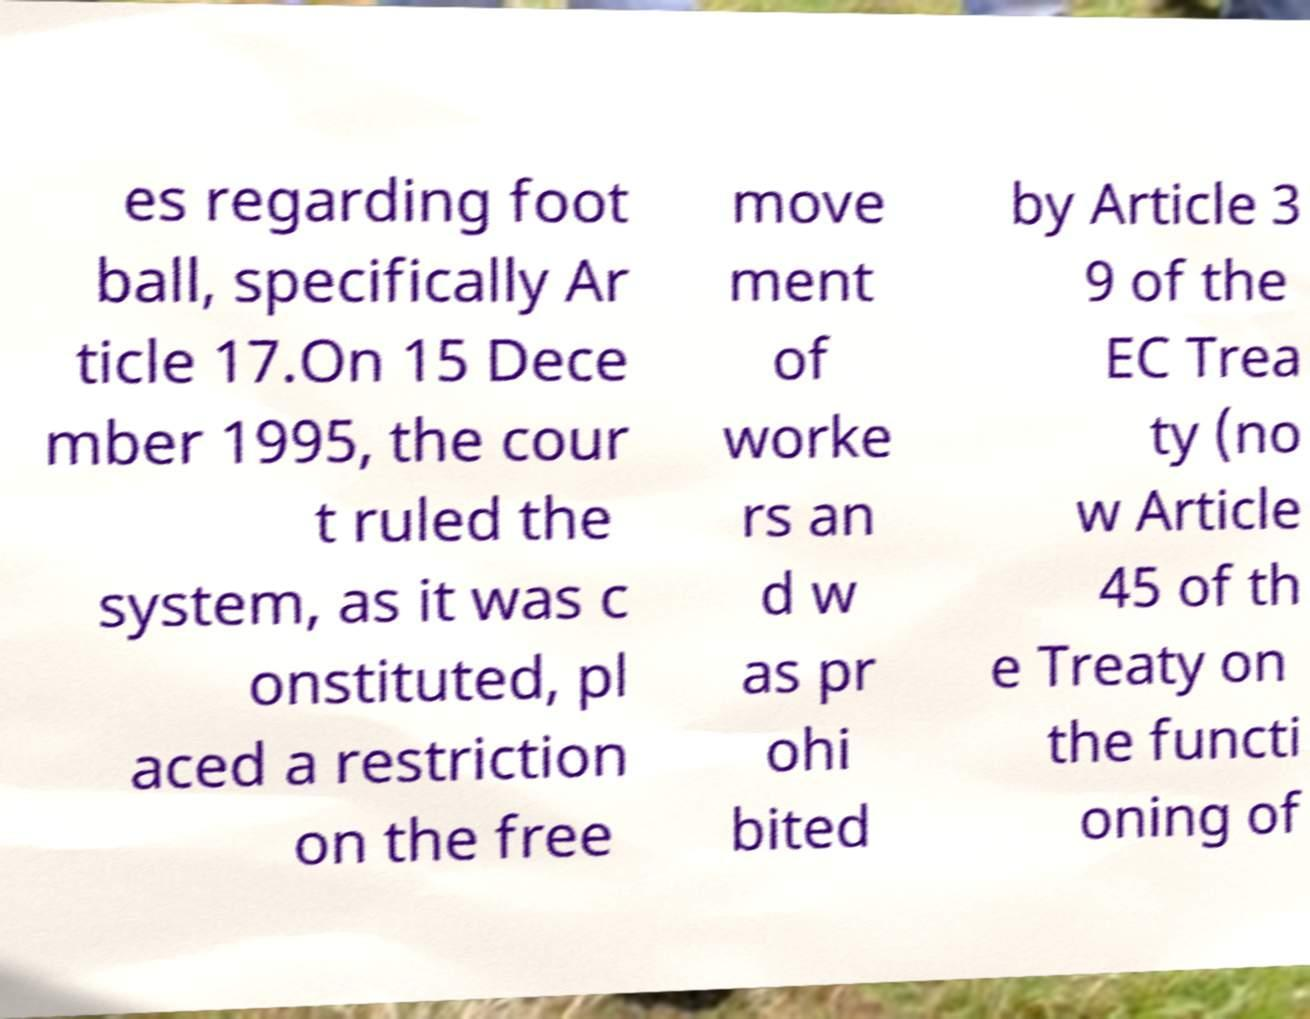Can you accurately transcribe the text from the provided image for me? es regarding foot ball, specifically Ar ticle 17.On 15 Dece mber 1995, the cour t ruled the system, as it was c onstituted, pl aced a restriction on the free move ment of worke rs an d w as pr ohi bited by Article 3 9 of the EC Trea ty (no w Article 45 of th e Treaty on the functi oning of 